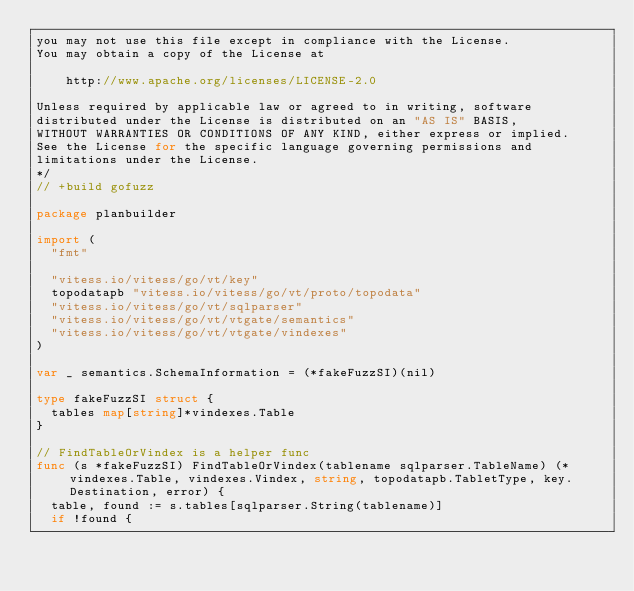<code> <loc_0><loc_0><loc_500><loc_500><_Go_>you may not use this file except in compliance with the License.
You may obtain a copy of the License at

    http://www.apache.org/licenses/LICENSE-2.0

Unless required by applicable law or agreed to in writing, software
distributed under the License is distributed on an "AS IS" BASIS,
WITHOUT WARRANTIES OR CONDITIONS OF ANY KIND, either express or implied.
See the License for the specific language governing permissions and
limitations under the License.
*/
// +build gofuzz

package planbuilder

import (
	"fmt"

	"vitess.io/vitess/go/vt/key"
	topodatapb "vitess.io/vitess/go/vt/proto/topodata"
	"vitess.io/vitess/go/vt/sqlparser"
	"vitess.io/vitess/go/vt/vtgate/semantics"
	"vitess.io/vitess/go/vt/vtgate/vindexes"
)

var _ semantics.SchemaInformation = (*fakeFuzzSI)(nil)

type fakeFuzzSI struct {
	tables map[string]*vindexes.Table
}

// FindTableOrVindex is a helper func
func (s *fakeFuzzSI) FindTableOrVindex(tablename sqlparser.TableName) (*vindexes.Table, vindexes.Vindex, string, topodatapb.TabletType, key.Destination, error) {
	table, found := s.tables[sqlparser.String(tablename)]
	if !found {</code> 